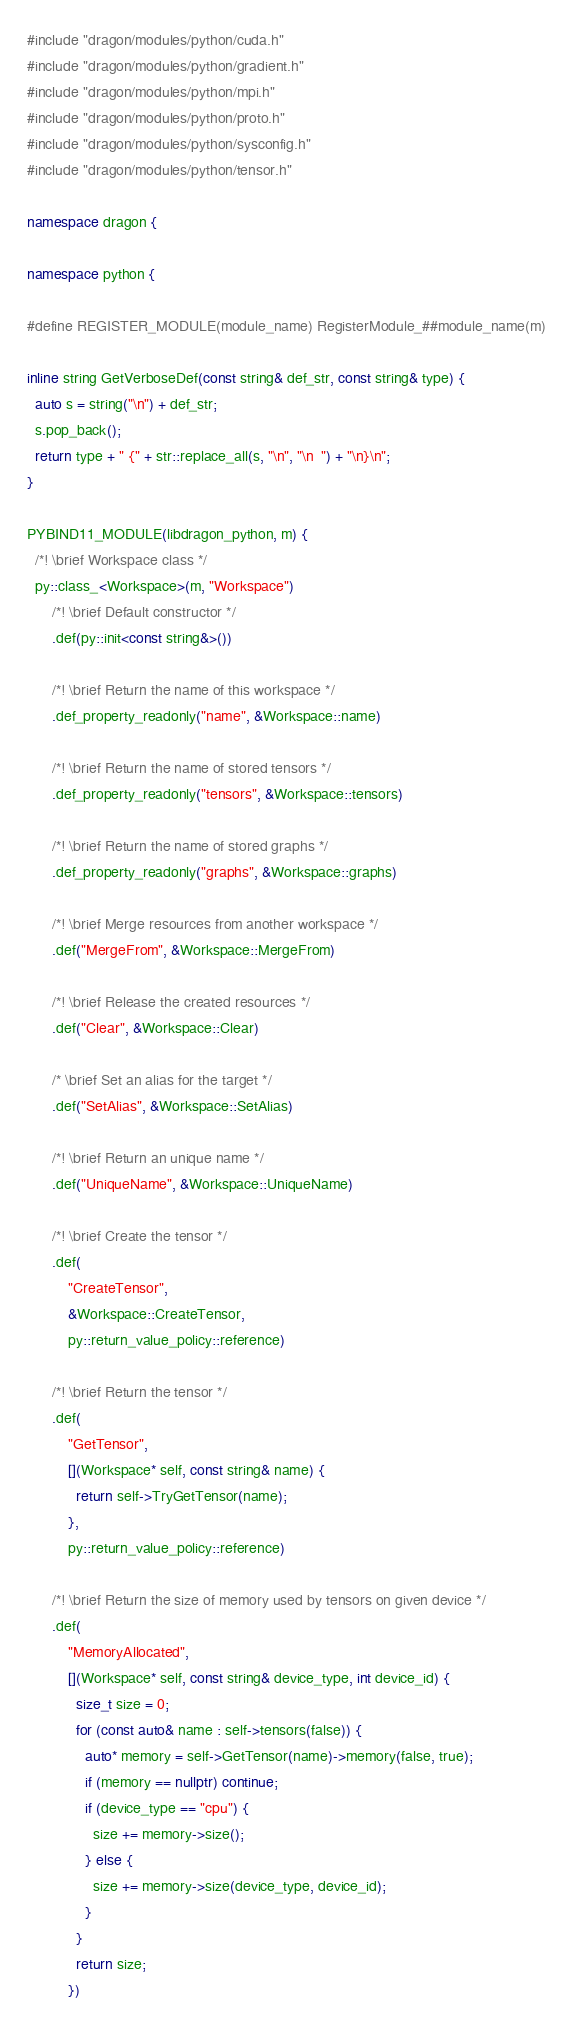Convert code to text. <code><loc_0><loc_0><loc_500><loc_500><_C++_>#include "dragon/modules/python/cuda.h"
#include "dragon/modules/python/gradient.h"
#include "dragon/modules/python/mpi.h"
#include "dragon/modules/python/proto.h"
#include "dragon/modules/python/sysconfig.h"
#include "dragon/modules/python/tensor.h"

namespace dragon {

namespace python {

#define REGISTER_MODULE(module_name) RegisterModule_##module_name(m)

inline string GetVerboseDef(const string& def_str, const string& type) {
  auto s = string("\n") + def_str;
  s.pop_back();
  return type + " {" + str::replace_all(s, "\n", "\n  ") + "\n}\n";
}

PYBIND11_MODULE(libdragon_python, m) {
  /*! \brief Workspace class */
  py::class_<Workspace>(m, "Workspace")
      /*! \brief Default constructor */
      .def(py::init<const string&>())

      /*! \brief Return the name of this workspace */
      .def_property_readonly("name", &Workspace::name)

      /*! \brief Return the name of stored tensors */
      .def_property_readonly("tensors", &Workspace::tensors)

      /*! \brief Return the name of stored graphs */
      .def_property_readonly("graphs", &Workspace::graphs)

      /*! \brief Merge resources from another workspace */
      .def("MergeFrom", &Workspace::MergeFrom)

      /*! \brief Release the created resources */
      .def("Clear", &Workspace::Clear)

      /* \brief Set an alias for the target */
      .def("SetAlias", &Workspace::SetAlias)

      /*! \brief Return an unique name */
      .def("UniqueName", &Workspace::UniqueName)

      /*! \brief Create the tensor */
      .def(
          "CreateTensor",
          &Workspace::CreateTensor,
          py::return_value_policy::reference)

      /*! \brief Return the tensor */
      .def(
          "GetTensor",
          [](Workspace* self, const string& name) {
            return self->TryGetTensor(name);
          },
          py::return_value_policy::reference)

      /*! \brief Return the size of memory used by tensors on given device */
      .def(
          "MemoryAllocated",
          [](Workspace* self, const string& device_type, int device_id) {
            size_t size = 0;
            for (const auto& name : self->tensors(false)) {
              auto* memory = self->GetTensor(name)->memory(false, true);
              if (memory == nullptr) continue;
              if (device_type == "cpu") {
                size += memory->size();
              } else {
                size += memory->size(device_type, device_id);
              }
            }
            return size;
          })
</code> 